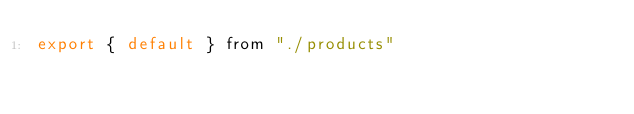Convert code to text. <code><loc_0><loc_0><loc_500><loc_500><_JavaScript_>export { default } from "./products"
</code> 